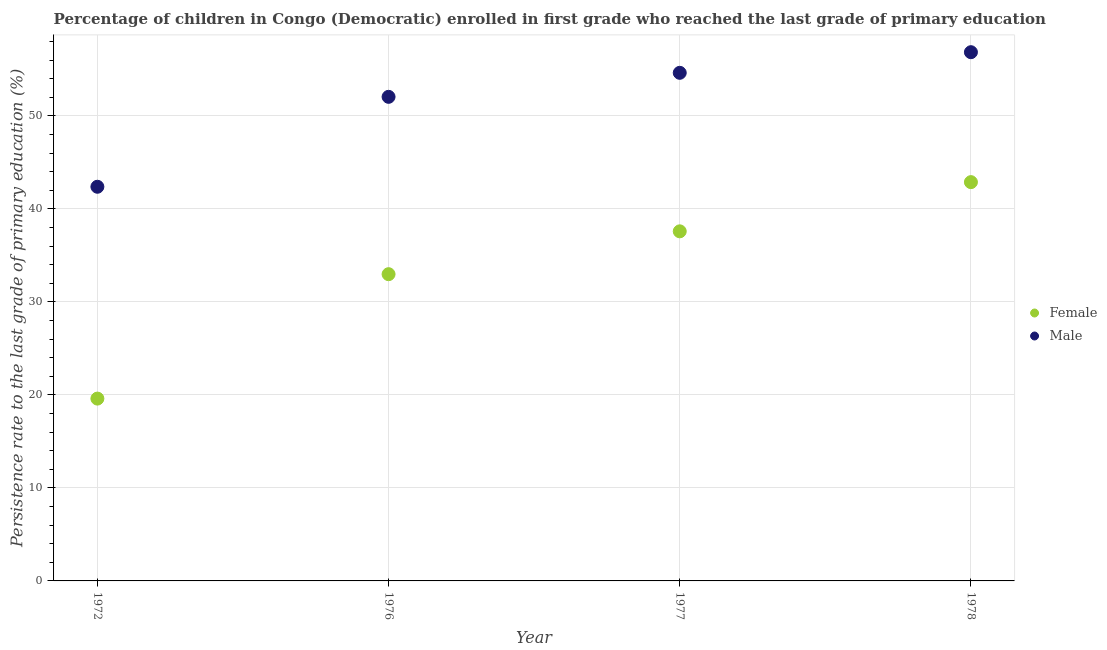Is the number of dotlines equal to the number of legend labels?
Provide a short and direct response. Yes. What is the persistence rate of female students in 1972?
Your answer should be very brief. 19.61. Across all years, what is the maximum persistence rate of female students?
Provide a succinct answer. 42.88. Across all years, what is the minimum persistence rate of male students?
Provide a short and direct response. 42.39. In which year was the persistence rate of female students maximum?
Your answer should be compact. 1978. What is the total persistence rate of male students in the graph?
Provide a succinct answer. 205.95. What is the difference between the persistence rate of female students in 1972 and that in 1977?
Ensure brevity in your answer.  -17.99. What is the difference between the persistence rate of male students in 1972 and the persistence rate of female students in 1976?
Offer a terse response. 9.4. What is the average persistence rate of female students per year?
Make the answer very short. 33.27. In the year 1977, what is the difference between the persistence rate of male students and persistence rate of female students?
Offer a terse response. 17.05. What is the ratio of the persistence rate of male students in 1976 to that in 1977?
Your answer should be very brief. 0.95. What is the difference between the highest and the second highest persistence rate of female students?
Offer a very short reply. 5.29. What is the difference between the highest and the lowest persistence rate of male students?
Ensure brevity in your answer.  14.47. Is the sum of the persistence rate of male students in 1976 and 1978 greater than the maximum persistence rate of female students across all years?
Your response must be concise. Yes. Does the persistence rate of male students monotonically increase over the years?
Give a very brief answer. Yes. Is the persistence rate of female students strictly greater than the persistence rate of male students over the years?
Provide a short and direct response. No. Is the persistence rate of male students strictly less than the persistence rate of female students over the years?
Offer a terse response. No. What is the difference between two consecutive major ticks on the Y-axis?
Your response must be concise. 10. Are the values on the major ticks of Y-axis written in scientific E-notation?
Provide a succinct answer. No. Does the graph contain grids?
Provide a short and direct response. Yes. How are the legend labels stacked?
Give a very brief answer. Vertical. What is the title of the graph?
Your answer should be very brief. Percentage of children in Congo (Democratic) enrolled in first grade who reached the last grade of primary education. Does "From production" appear as one of the legend labels in the graph?
Offer a very short reply. No. What is the label or title of the X-axis?
Your response must be concise. Year. What is the label or title of the Y-axis?
Your response must be concise. Persistence rate to the last grade of primary education (%). What is the Persistence rate to the last grade of primary education (%) in Female in 1972?
Keep it short and to the point. 19.61. What is the Persistence rate to the last grade of primary education (%) of Male in 1972?
Offer a terse response. 42.39. What is the Persistence rate to the last grade of primary education (%) in Female in 1976?
Give a very brief answer. 32.99. What is the Persistence rate to the last grade of primary education (%) in Male in 1976?
Your answer should be very brief. 52.06. What is the Persistence rate to the last grade of primary education (%) in Female in 1977?
Provide a short and direct response. 37.59. What is the Persistence rate to the last grade of primary education (%) of Male in 1977?
Give a very brief answer. 54.64. What is the Persistence rate to the last grade of primary education (%) in Female in 1978?
Provide a short and direct response. 42.88. What is the Persistence rate to the last grade of primary education (%) of Male in 1978?
Provide a short and direct response. 56.86. Across all years, what is the maximum Persistence rate to the last grade of primary education (%) in Female?
Ensure brevity in your answer.  42.88. Across all years, what is the maximum Persistence rate to the last grade of primary education (%) of Male?
Provide a succinct answer. 56.86. Across all years, what is the minimum Persistence rate to the last grade of primary education (%) in Female?
Your answer should be compact. 19.61. Across all years, what is the minimum Persistence rate to the last grade of primary education (%) in Male?
Your answer should be compact. 42.39. What is the total Persistence rate to the last grade of primary education (%) of Female in the graph?
Your response must be concise. 133.07. What is the total Persistence rate to the last grade of primary education (%) in Male in the graph?
Keep it short and to the point. 205.95. What is the difference between the Persistence rate to the last grade of primary education (%) of Female in 1972 and that in 1976?
Your response must be concise. -13.38. What is the difference between the Persistence rate to the last grade of primary education (%) of Male in 1972 and that in 1976?
Your answer should be compact. -9.67. What is the difference between the Persistence rate to the last grade of primary education (%) in Female in 1972 and that in 1977?
Ensure brevity in your answer.  -17.99. What is the difference between the Persistence rate to the last grade of primary education (%) in Male in 1972 and that in 1977?
Keep it short and to the point. -12.25. What is the difference between the Persistence rate to the last grade of primary education (%) of Female in 1972 and that in 1978?
Keep it short and to the point. -23.28. What is the difference between the Persistence rate to the last grade of primary education (%) in Male in 1972 and that in 1978?
Make the answer very short. -14.47. What is the difference between the Persistence rate to the last grade of primary education (%) in Female in 1976 and that in 1977?
Give a very brief answer. -4.61. What is the difference between the Persistence rate to the last grade of primary education (%) in Male in 1976 and that in 1977?
Offer a terse response. -2.58. What is the difference between the Persistence rate to the last grade of primary education (%) in Female in 1976 and that in 1978?
Offer a very short reply. -9.9. What is the difference between the Persistence rate to the last grade of primary education (%) in Male in 1976 and that in 1978?
Give a very brief answer. -4.8. What is the difference between the Persistence rate to the last grade of primary education (%) of Female in 1977 and that in 1978?
Provide a succinct answer. -5.29. What is the difference between the Persistence rate to the last grade of primary education (%) of Male in 1977 and that in 1978?
Your answer should be very brief. -2.22. What is the difference between the Persistence rate to the last grade of primary education (%) in Female in 1972 and the Persistence rate to the last grade of primary education (%) in Male in 1976?
Make the answer very short. -32.45. What is the difference between the Persistence rate to the last grade of primary education (%) in Female in 1972 and the Persistence rate to the last grade of primary education (%) in Male in 1977?
Provide a short and direct response. -35.03. What is the difference between the Persistence rate to the last grade of primary education (%) of Female in 1972 and the Persistence rate to the last grade of primary education (%) of Male in 1978?
Keep it short and to the point. -37.25. What is the difference between the Persistence rate to the last grade of primary education (%) in Female in 1976 and the Persistence rate to the last grade of primary education (%) in Male in 1977?
Your response must be concise. -21.65. What is the difference between the Persistence rate to the last grade of primary education (%) of Female in 1976 and the Persistence rate to the last grade of primary education (%) of Male in 1978?
Provide a succinct answer. -23.87. What is the difference between the Persistence rate to the last grade of primary education (%) in Female in 1977 and the Persistence rate to the last grade of primary education (%) in Male in 1978?
Offer a very short reply. -19.26. What is the average Persistence rate to the last grade of primary education (%) of Female per year?
Ensure brevity in your answer.  33.27. What is the average Persistence rate to the last grade of primary education (%) of Male per year?
Offer a terse response. 51.49. In the year 1972, what is the difference between the Persistence rate to the last grade of primary education (%) of Female and Persistence rate to the last grade of primary education (%) of Male?
Your response must be concise. -22.78. In the year 1976, what is the difference between the Persistence rate to the last grade of primary education (%) of Female and Persistence rate to the last grade of primary education (%) of Male?
Give a very brief answer. -19.07. In the year 1977, what is the difference between the Persistence rate to the last grade of primary education (%) in Female and Persistence rate to the last grade of primary education (%) in Male?
Keep it short and to the point. -17.05. In the year 1978, what is the difference between the Persistence rate to the last grade of primary education (%) of Female and Persistence rate to the last grade of primary education (%) of Male?
Provide a short and direct response. -13.97. What is the ratio of the Persistence rate to the last grade of primary education (%) of Female in 1972 to that in 1976?
Offer a very short reply. 0.59. What is the ratio of the Persistence rate to the last grade of primary education (%) of Male in 1972 to that in 1976?
Provide a succinct answer. 0.81. What is the ratio of the Persistence rate to the last grade of primary education (%) in Female in 1972 to that in 1977?
Offer a terse response. 0.52. What is the ratio of the Persistence rate to the last grade of primary education (%) of Male in 1972 to that in 1977?
Offer a very short reply. 0.78. What is the ratio of the Persistence rate to the last grade of primary education (%) of Female in 1972 to that in 1978?
Give a very brief answer. 0.46. What is the ratio of the Persistence rate to the last grade of primary education (%) of Male in 1972 to that in 1978?
Your response must be concise. 0.75. What is the ratio of the Persistence rate to the last grade of primary education (%) in Female in 1976 to that in 1977?
Your response must be concise. 0.88. What is the ratio of the Persistence rate to the last grade of primary education (%) of Male in 1976 to that in 1977?
Give a very brief answer. 0.95. What is the ratio of the Persistence rate to the last grade of primary education (%) in Female in 1976 to that in 1978?
Keep it short and to the point. 0.77. What is the ratio of the Persistence rate to the last grade of primary education (%) in Male in 1976 to that in 1978?
Your response must be concise. 0.92. What is the ratio of the Persistence rate to the last grade of primary education (%) of Female in 1977 to that in 1978?
Your answer should be compact. 0.88. What is the difference between the highest and the second highest Persistence rate to the last grade of primary education (%) of Female?
Provide a short and direct response. 5.29. What is the difference between the highest and the second highest Persistence rate to the last grade of primary education (%) of Male?
Offer a terse response. 2.22. What is the difference between the highest and the lowest Persistence rate to the last grade of primary education (%) in Female?
Provide a succinct answer. 23.28. What is the difference between the highest and the lowest Persistence rate to the last grade of primary education (%) in Male?
Your response must be concise. 14.47. 